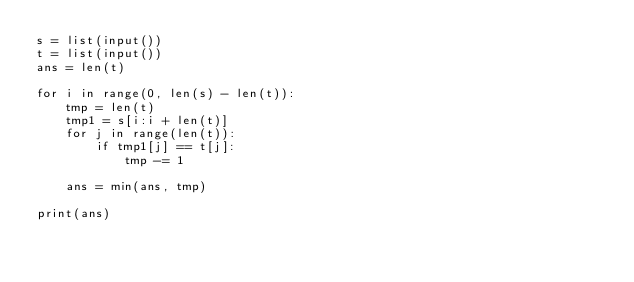Convert code to text. <code><loc_0><loc_0><loc_500><loc_500><_Python_>s = list(input())
t = list(input())
ans = len(t)

for i in range(0, len(s) - len(t)):
    tmp = len(t)
    tmp1 = s[i:i + len(t)]
    for j in range(len(t)):
        if tmp1[j] == t[j]:
            tmp -= 1

    ans = min(ans, tmp)

print(ans)
</code> 